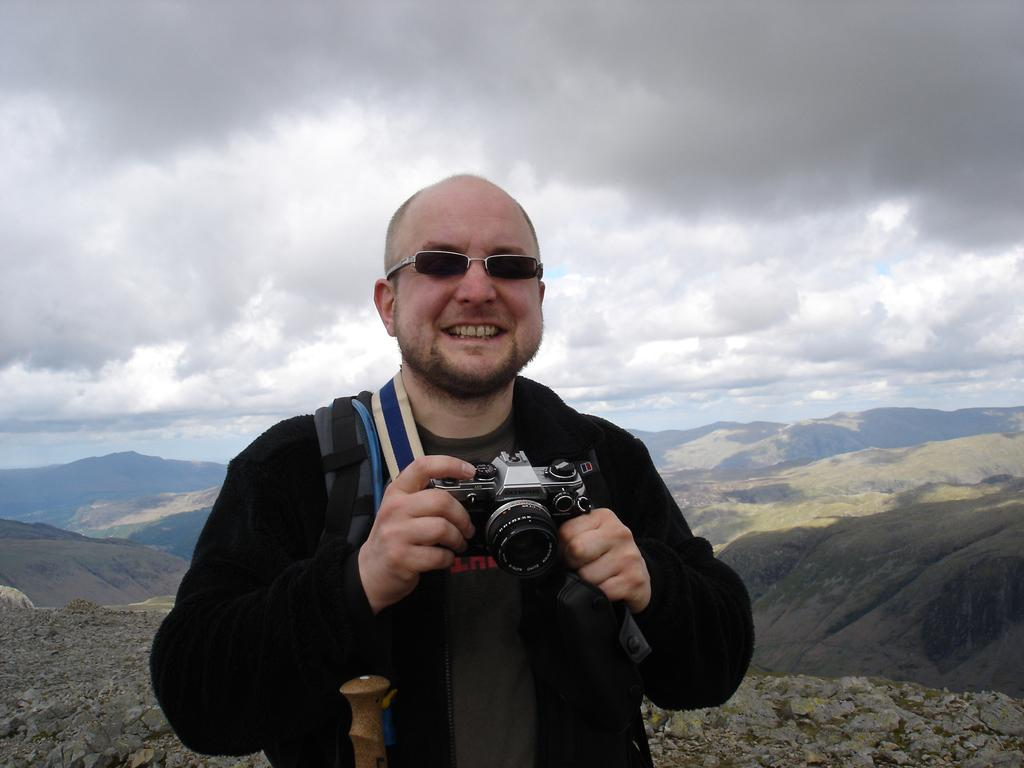What is the man in the image holding? The man is holding a camera. What is the man's facial expression in the image? The man is smiling. What accessory is the man wearing in the image? The man is wearing spectacles. What can be seen in the background of the image? There are hills and the sky visible in the background of the image. What is the condition of the sky in the image? The sky is full of clouds. What type of marble can be seen on the ground in the image? There is no marble visible on the ground in the image. What road is the man walking on in the image? There is no road present in the image; the man is standing in front of hills and the sky. 